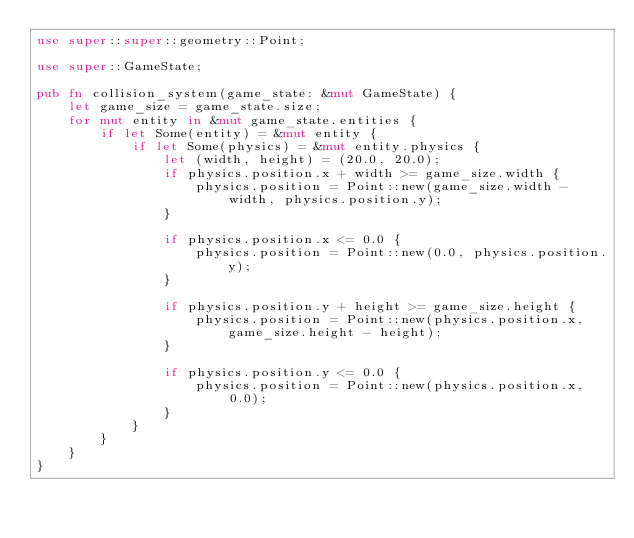<code> <loc_0><loc_0><loc_500><loc_500><_Rust_>use super::super::geometry::Point;

use super::GameState;

pub fn collision_system(game_state: &mut GameState) {
    let game_size = game_state.size;
    for mut entity in &mut game_state.entities {
        if let Some(entity) = &mut entity {
            if let Some(physics) = &mut entity.physics {
                let (width, height) = (20.0, 20.0);
                if physics.position.x + width >= game_size.width {
                    physics.position = Point::new(game_size.width - width, physics.position.y);
                }

                if physics.position.x <= 0.0 {
                    physics.position = Point::new(0.0, physics.position.y);
                }

                if physics.position.y + height >= game_size.height {
                    physics.position = Point::new(physics.position.x, game_size.height - height);
                }

                if physics.position.y <= 0.0 {
                    physics.position = Point::new(physics.position.x, 0.0);
                }
            }
        }
    }
}
</code> 